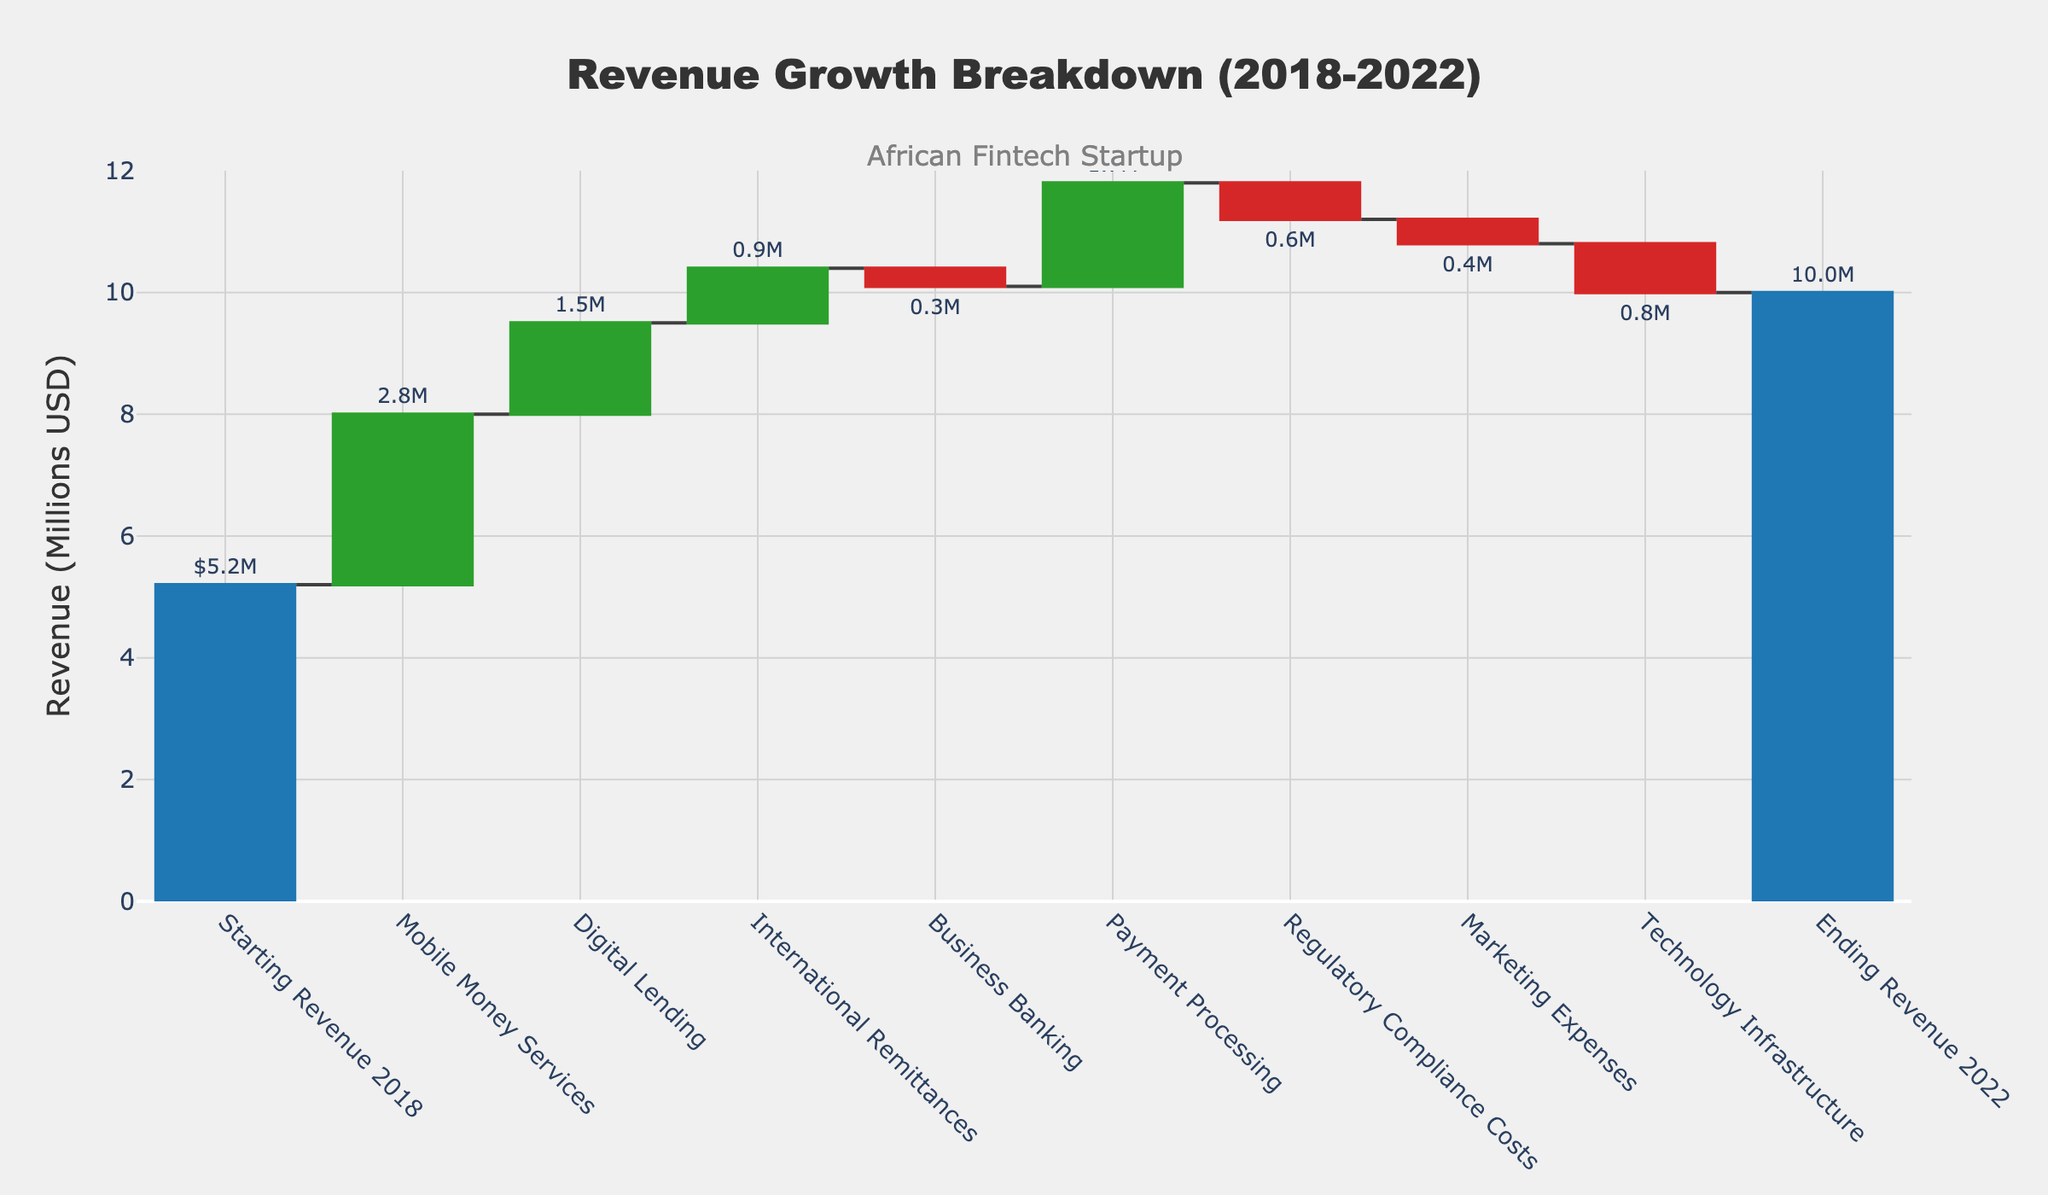What's the title of the chart? The title is bold and located at the top of the chart. It states "Revenue Growth Breakdown (2018-2022)".
Answer: Revenue Growth Breakdown (2018-2022) What are the different categories contributing to the revenue breakdown? The categories are listed along the x-axis of the chart. They include Starting Revenue 2018, Mobile Money Services, Digital Lending, International Remittances, Business Banking, Payment Processing, Regulatory Compliance Costs, Marketing Expenses, Technology Infrastructure, and Ending Revenue 2022.
Answer: Starting Revenue 2018, Mobile Money Services, Digital Lending, International Remittances, Business Banking, Payment Processing, Regulatory Compliance Costs, Marketing Expenses, Technology Infrastructure, Ending Revenue 2022 Which category has the highest positive contribution to the revenue growth? By examining the bars of the chart, the tallest green bar indicates that Mobile Money Services has the highest positive contribution of 2.8M.
Answer: Mobile Money Services What is the final revenue of the startup in 2022? The final point on the chart, labeled as Ending Revenue 2022, indicates the final revenue value. It reached 10M USD.
Answer: 10M USD Calculate the total negative impact on revenue from the listed expenses. Sum the negative contributions: Business Banking (-0.3M), Regulatory Compliance Costs (-0.6M), Marketing Expenses (-0.4M), Technology Infrastructure (-0.8M). Total = -0.3M -0.6M -0.4M -0.8M = -2.1M.
Answer: -2.1M What is the difference between the highest positive contribution and the highest negative contribution? The highest positive contribution is from Mobile Money Services (2.8M), and the highest negative contribution is from Technology Infrastructure (-0.8M). Difference = 2.8M - (-0.8M) = 2.8M + 0.8M = 3.6M.
Answer: 3.6M By how much did the revenue increase from the start to the end period? The initial revenue is given by Starting Revenue 2018 (5.2M) and the final revenue is Ending Revenue 2022 (10M). Increase = 10M - 5.2M = 4.8M.
Answer: 4.8M Which category has a negative impact on the revenue breakdown? The red bars indicate negative contributions. They are Business Banking, Regulatory Compliance Costs, Marketing Expenses, and Technology Infrastructure.
Answer: Business Banking, Regulatory Compliance Costs, Marketing Expenses, Technology Infrastructure If Technology Infrastructure costs had been zero, what would the ending revenue be? The current ending revenue is 10M, and Technology Infrastructure's negative impact is -0.8M. Without this cost, the revenue would be 10M + 0.8M = 10.8M.
Answer: 10.8M 